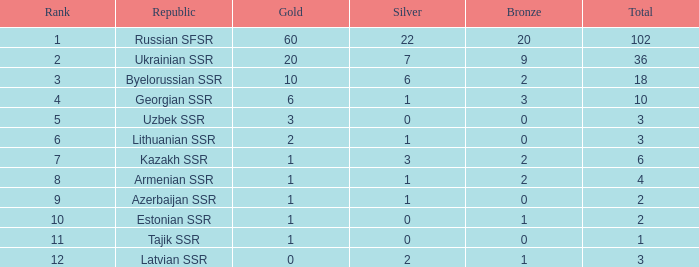What is the maximum amount of bronzes for teams positioned at 7th place with over 0 silver? 2.0. 